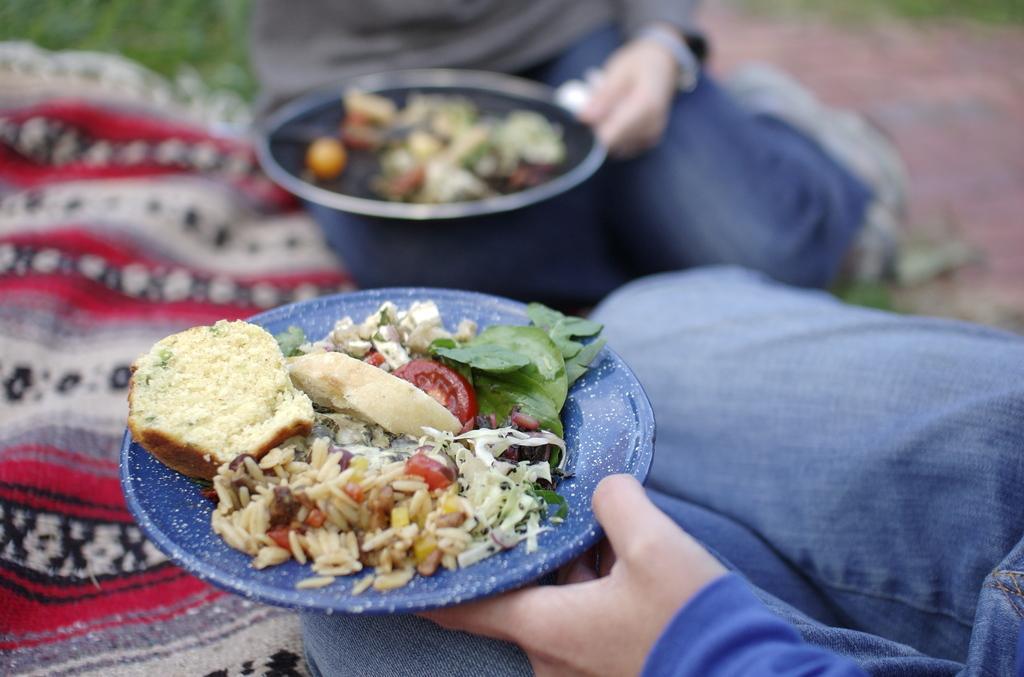Describe this image in one or two sentences. In the image there are two people, they are holding some food items in a plate with their hands. 